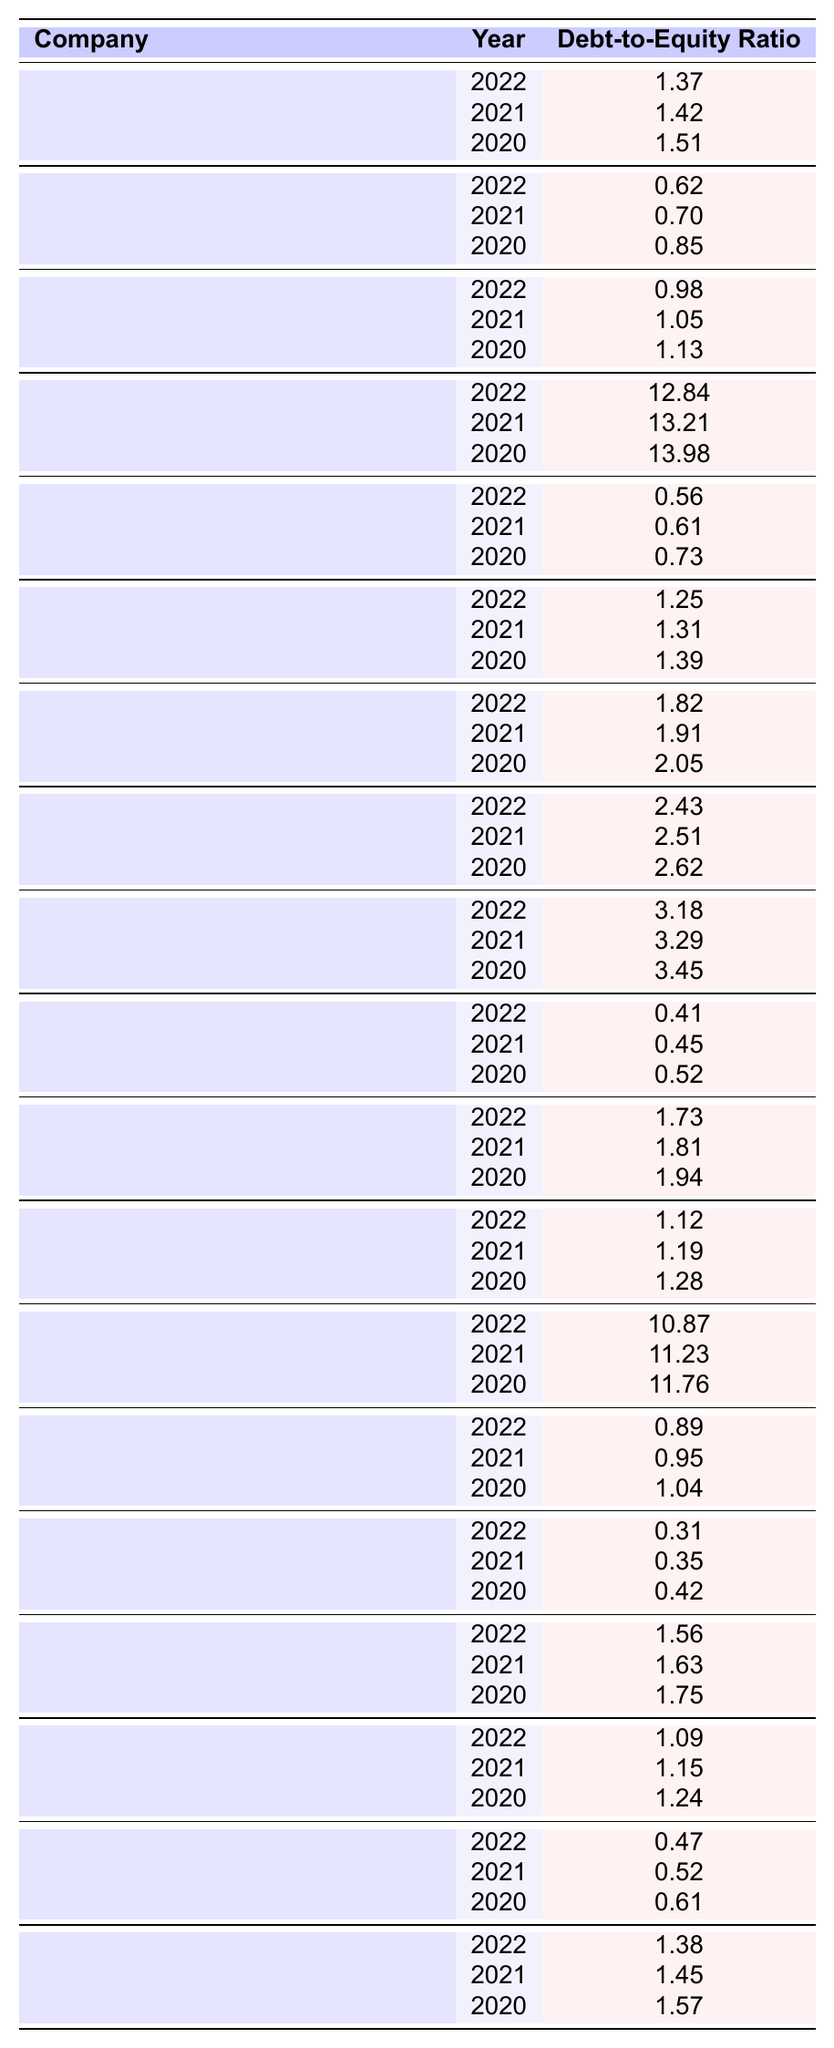What is the debt-to-equity ratio of Galp Energia in 2022? From the table, Galp Energia's debt-to-equity ratio for the year 2022 is directly listed as 0.62.
Answer: 0.62 Which company has the highest debt-to-equity ratio in 2022? In 2022, the table shows Banco Comercial Português with a debt-to-equity ratio of 12.84, which is the highest compared to all other companies listed for that year.
Answer: Banco Comercial Português What was the trend in the debt-to-equity ratio for EDP - Energias de Portugal from 2020 to 2022? Looking at the values: 1.51 in 2020, 1.42 in 2021, and 1.37 in 2022, we see a decreasing trend over this period.
Answer: Decreasing Calculate the average debt-to-equity ratio for The Navigator Company over the three years. The ratios for The Navigator Company are 0.73 (2020), 0.61 (2021), and 0.56 (2022). Adding them (0.73 + 0.61 + 0.56 = 1.90) and dividing by the number of years (3) gives an average of 0.63.
Answer: 0.63 Is the debt-to-equity ratio of Sonae consistently below 2.0 from 2020 to 2022? The ratios for Sonae for the years 2020, 2021, and 2022 are 1.39, 1.31, and 1.25, all of which are indeed below 2.0.
Answer: Yes What was the difference in the debt-to-equity ratio between Banco BPI in 2020 and 2022? Banco BPI's ratios are 11.76 in 2020 and 10.87 in 2022. The difference is calculated by subtracting 10.87 from 11.76, which equals 0.89.
Answer: 0.89 Which company shows the most improvement in its debt-to-equity ratio over the recorded years? By comparing each company's values, The Navigator Company improved from 0.73 (2020) to 0.56 (2022), showing a decrease of 0.17, the largest improvement among all companies.
Answer: The Navigator Company What is the median debt-to-equity ratio for all companies in 2022? Arranging the 2022 ratios in ascending order, the middle values are for Altri (0.89) and Corticeira Amorim (0.41), averaging these two gives the median of 0.65.
Answer: 0.65 Is there a company with a debt-to-equity ratio below 0.5 in any of the years listed? The table indicates that the lowest ratio is for Novabase in 2022 at 0.31, which is below 0.5, making this a yes.
Answer: Yes Did any company have a debt-to-equity ratio above 10.0 in 2021? Checking the data, Banco BPI had a ratio of 11.23 in 2021, which is above 10.0. Therefore, the answer is yes.
Answer: Yes Compare the debt-to-equity ratio for Mota-Engil in 2020 and 2021. Mota-Engil had a ratio of 3.45 in 2020 and 3.29 in 2021. Comparing these two, the ratio decreased by 0.16 from 2020 to 2021.
Answer: Decreased by 0.16 